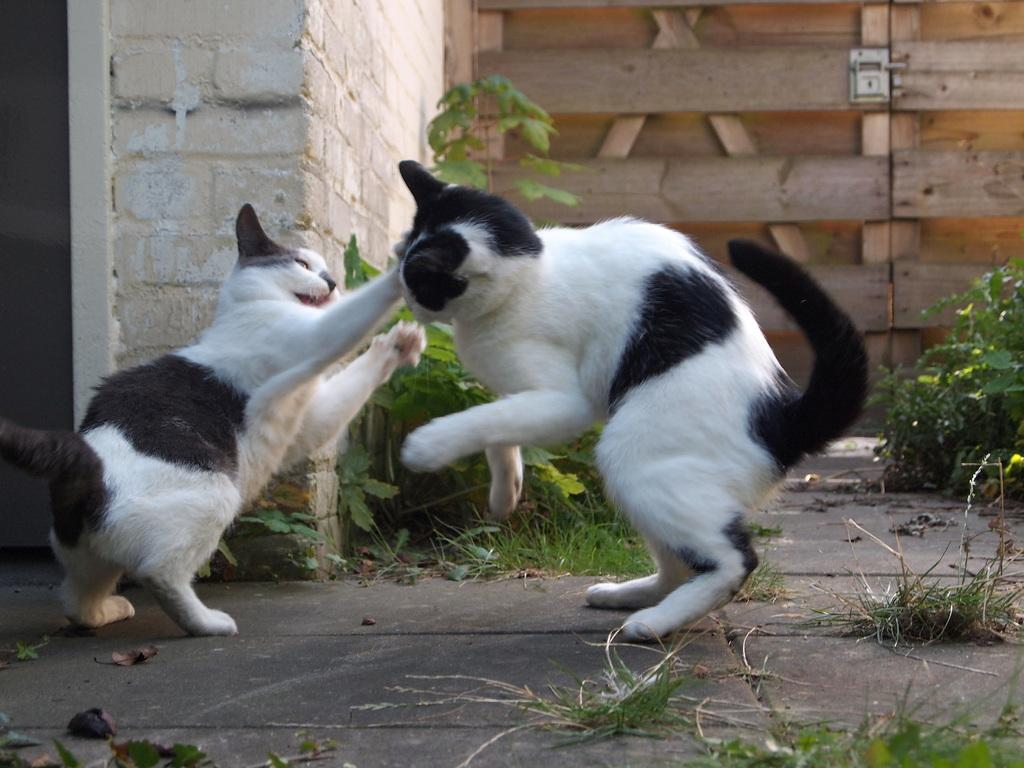What type of living organisms can be seen in the image? There are animals in the image. What colors are the animals in the image? The animals are in white and black color. What can be seen to the right of the image? There are plants to the right of the image. What architectural features are visible in the background of the image? There is a wall and a wooden door in the background of the image. How many bears are sitting on the seat in the image? There are no bears or seats present in the image. What type of plant is growing on the left side of the image? The image does not show any plants on the left side; there are only plants to the right. 